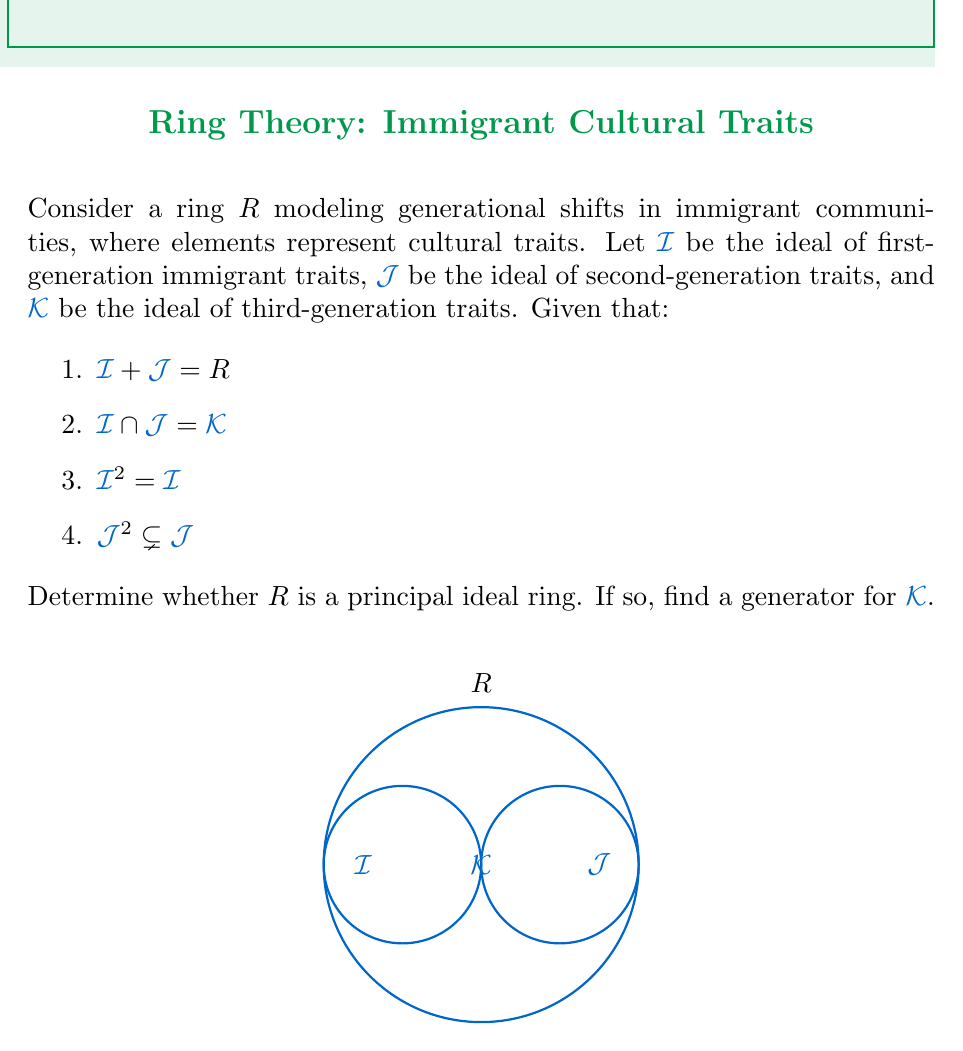Can you answer this question? Let's approach this step-by-step:

1) First, we need to understand what these conditions mean in the context of our ring:
   - $I + J = R$ means that every cultural trait can be expressed as a combination of first and second-generation traits.
   - $I \cap J = K$ means that traits common to both first and second generations form the third-generation traits.
   - $I^2 = I$ suggests that first-generation traits are stable and self-reproducing.
   - $J^2 \subsetneq J$ indicates that second-generation traits are evolving, not all combinations of second-generation traits remain in the second generation.

2) To determine if $R$ is a principal ideal ring, we need to check if every ideal in $R$ is generated by a single element.

3) We know that $I$ and $J$ are comaximal (their sum is the entire ring). In a principal ideal ring, this would imply that $I$ and $J$ are generated by elements $a$ and $b$ respectively, where $a + b = 1$.

4) If $R$ were a principal ideal ring, then $K = I \cap J$ would also be principal. Let's assume $K = (k)$ for some $k \in R$.

5) In a principal ideal ring, the intersection of two principal ideals $(a)$ and $(b)$ is equal to the principal ideal generated by their least common multiple: $(a) \cap (b) = (lcm(a,b))$.

6) Given that $I^2 = I$, we can deduce that $I = (e)$ where $e$ is an idempotent element ($e^2 = e$).

7) However, the condition $J^2 \subsetneq J$ contradicts the possibility of $J$ being a principal ideal. If $J$ were principal, say $J = (j)$, then $J^2 = (j^2) = (j) = J$, which is not the case here.

8) This contradiction proves that $R$ cannot be a principal ideal ring.

Therefore, we cannot find a single generator for $K$, as $R$ is not a principal ideal ring.
Answer: $R$ is not a principal ideal ring. 